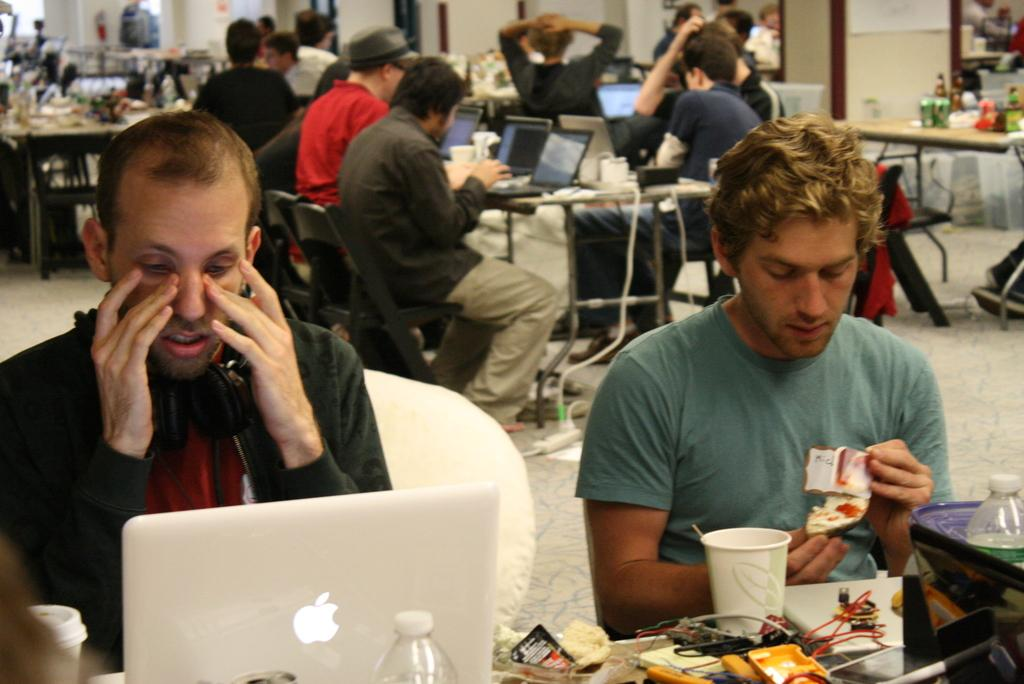What can be seen in the background of the image? There is a wall in the image. What are the people in the image doing? The people are sitting on chairs in the image. What is on the table in the image? There is a bottle, a glass, and a laptop on the table in the image. What design is featured on the dime that is visible in the image? There is no dime present in the image. What causes the people in the image to feel shame? There is no indication of shame or any emotional state in the image; it simply shows people sitting on chairs. 